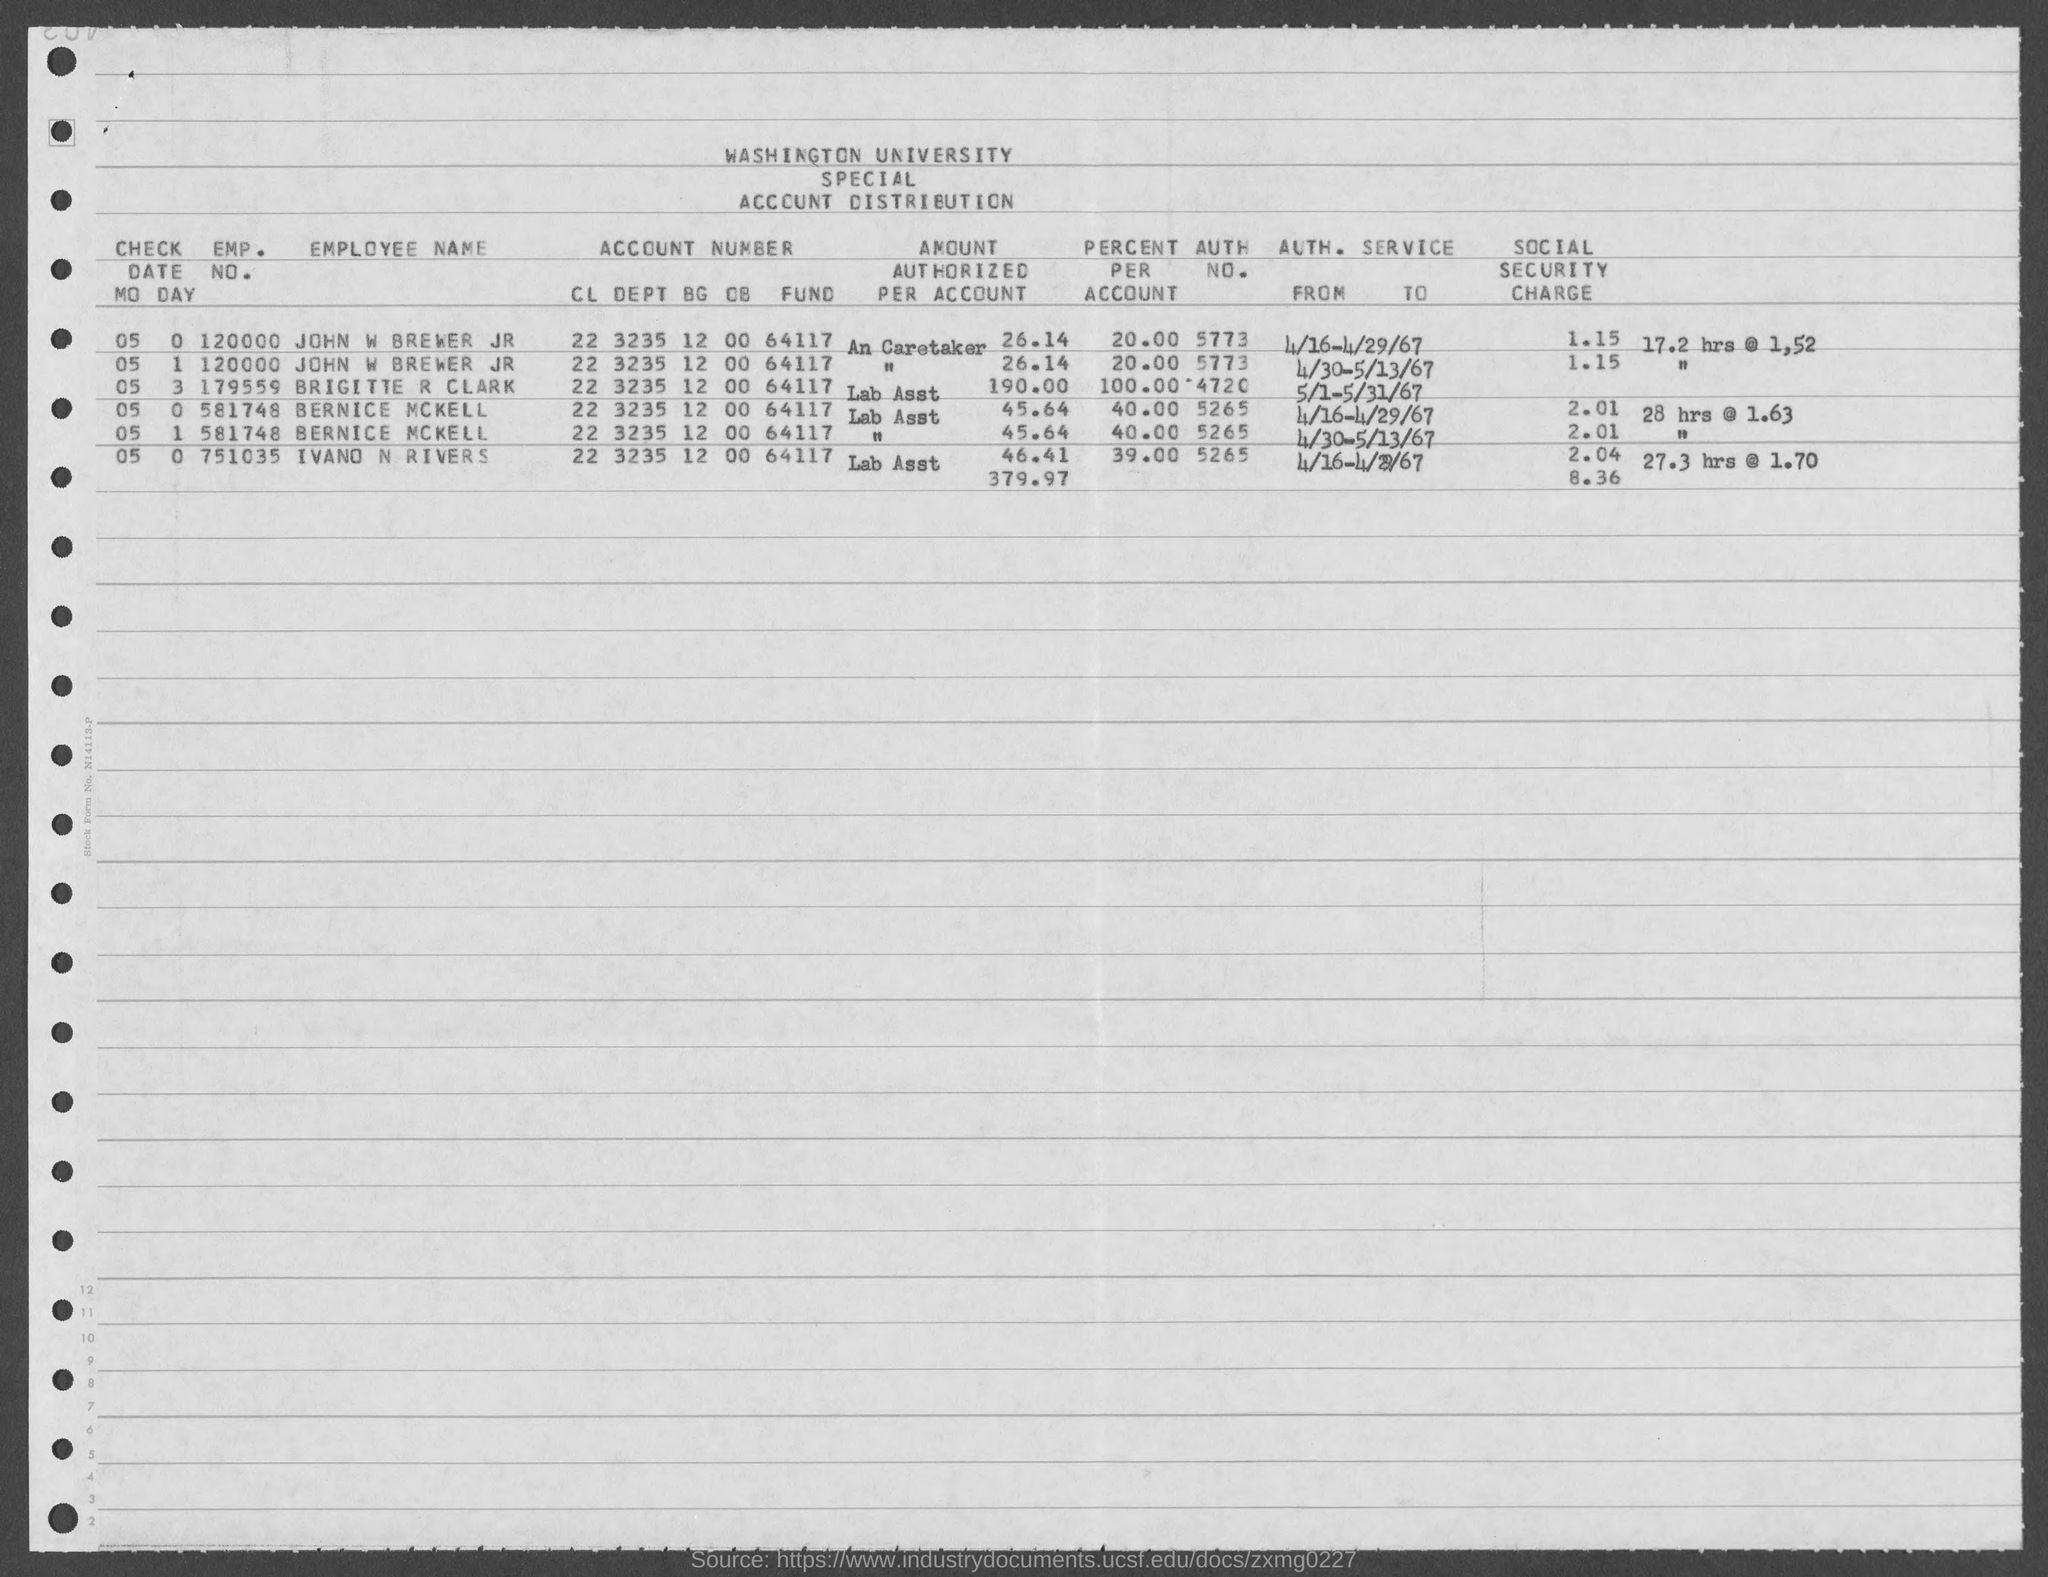Point out several critical features in this image. Washington University is the name of the university mentioned in the given form. The emp. no. of Bernice McKell mentioned in the given form is 581748... The account number of John W. Brewer Jr. as mentioned on the given page is 22 3235 12 00 64117. The emp. no. of ivand n rivers mentioned in the given page is 751035. The given text is asking for the employer number of John W Brewer as mentioned on the given page. The number is 120000. 